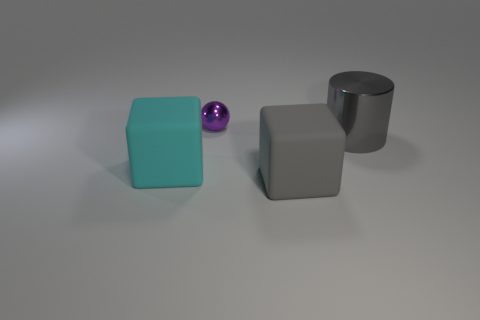Add 3 big gray matte spheres. How many objects exist? 7 Add 2 purple balls. How many purple balls are left? 3 Add 3 matte objects. How many matte objects exist? 5 Subtract 0 yellow cylinders. How many objects are left? 4 Subtract all spheres. How many objects are left? 3 Subtract all tiny spheres. Subtract all large cylinders. How many objects are left? 2 